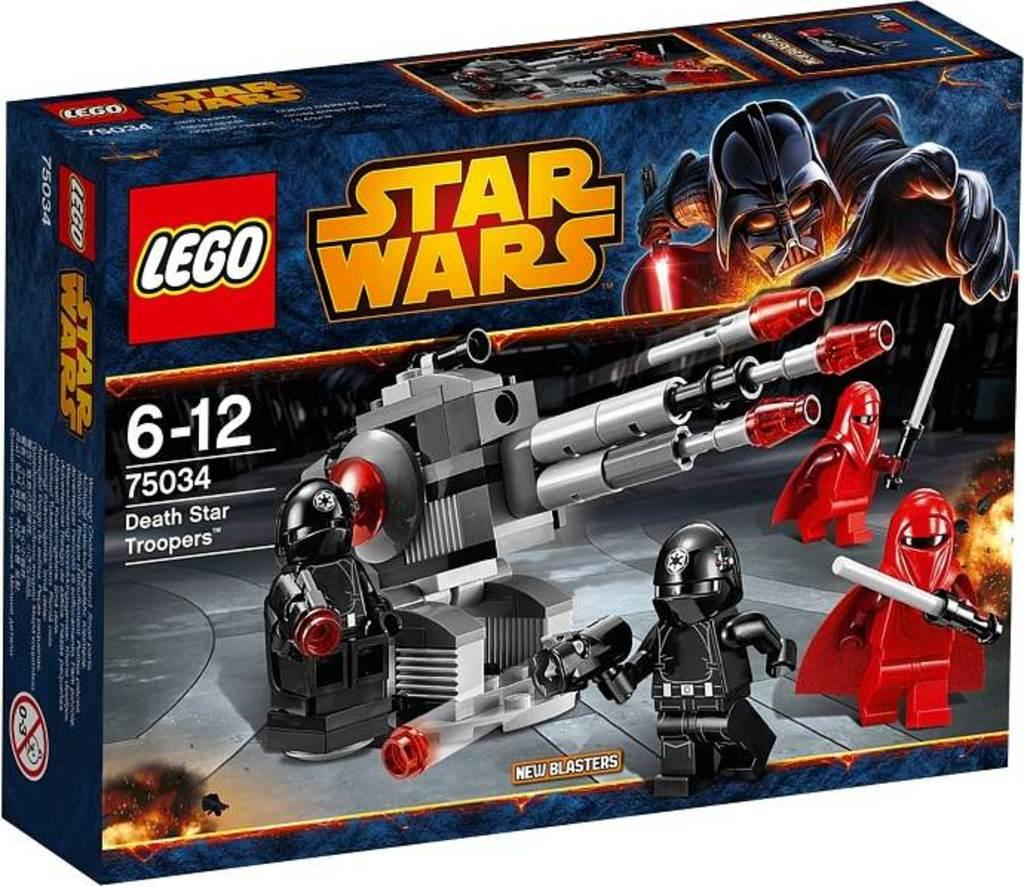Provide a one-sentence caption for the provided image. A Lego Star Wars play set number 75034. 